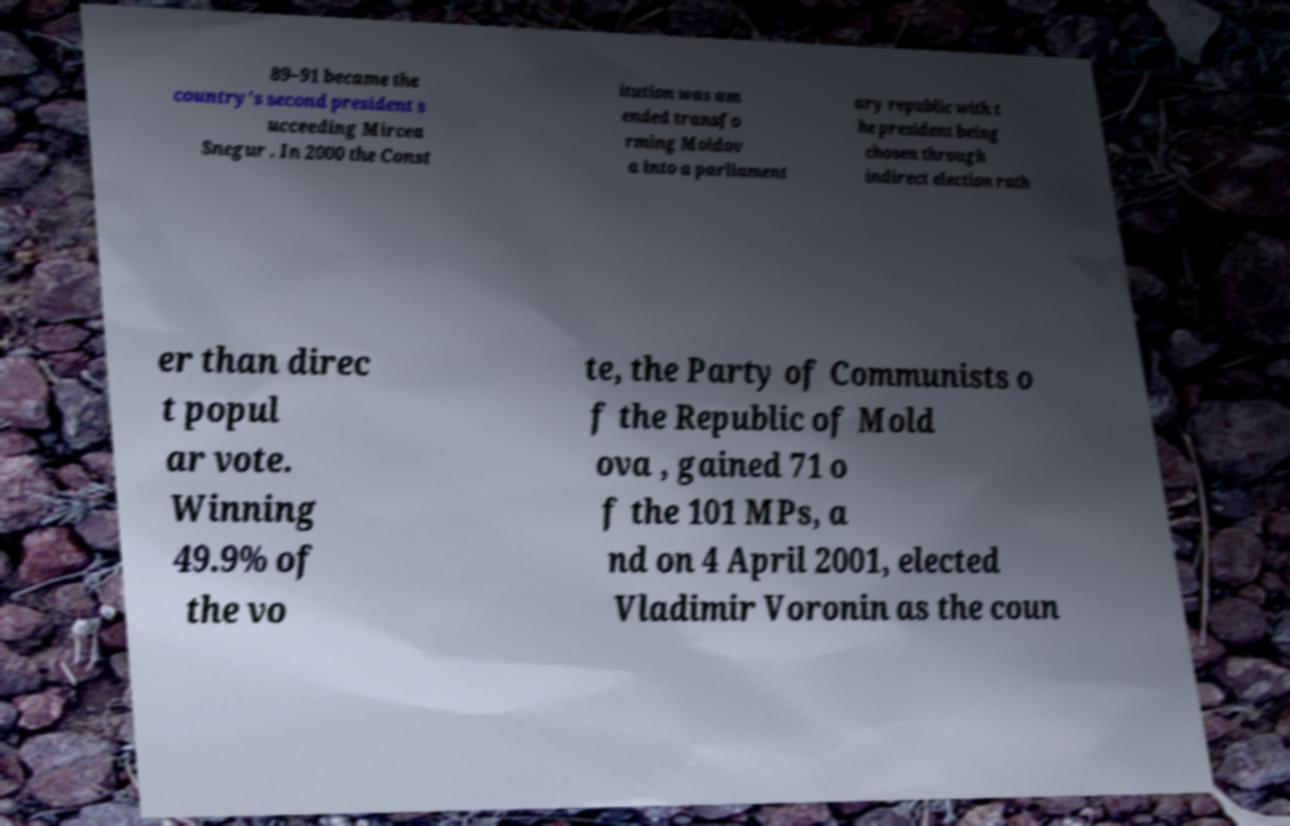What messages or text are displayed in this image? I need them in a readable, typed format. 89–91 became the country's second president s ucceeding Mircea Snegur . In 2000 the Const itution was am ended transfo rming Moldov a into a parliament ary republic with t he president being chosen through indirect election rath er than direc t popul ar vote. Winning 49.9% of the vo te, the Party of Communists o f the Republic of Mold ova , gained 71 o f the 101 MPs, a nd on 4 April 2001, elected Vladimir Voronin as the coun 